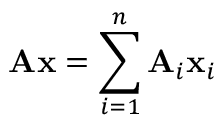<formula> <loc_0><loc_0><loc_500><loc_500>A x = \sum _ { i = 1 } ^ { n } A _ { i } x _ { i }</formula> 